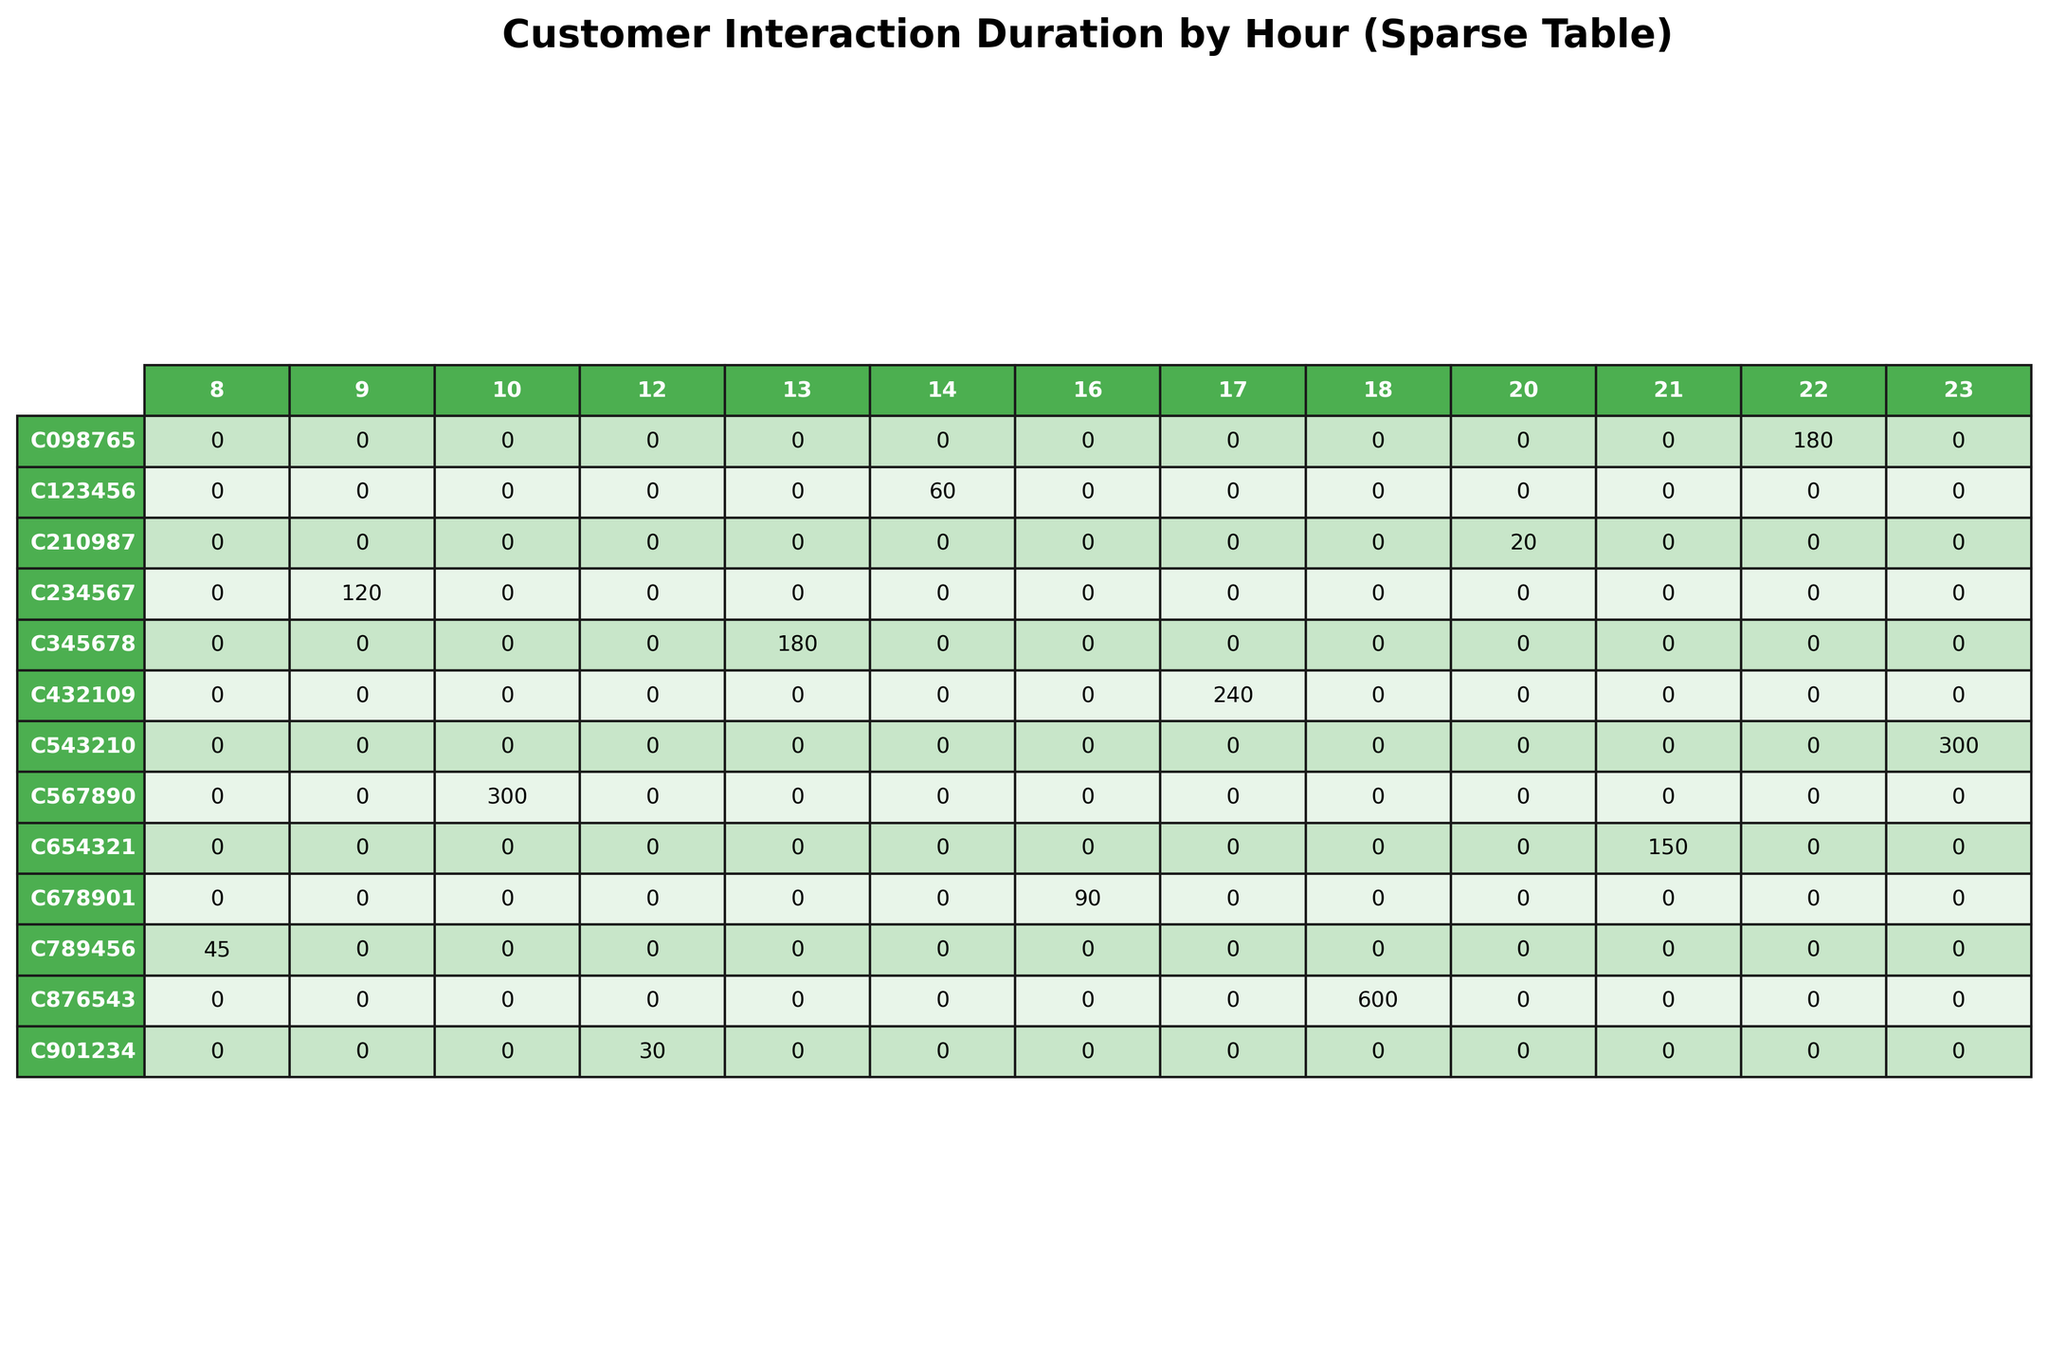What is the total interaction duration for customer C567890? The interaction duration for customer C567890 can be found in the table under their row. It shows a total of 300 seconds across the hours listed.
Answer: 300 seconds Which customer had the longest interaction time during the hour of 12 PM? By examining the table for the 12 PM column, we see that the customer with ID C901234 had an interaction duration of 30 seconds, which is the only entry for that hour.
Answer: C901234 How many total seconds did customer C789456 spend interacting with products during all hours? Looking at the row for customer C789456, the total duration is 45 seconds, which is the only entry for this customer across all hours.
Answer: 45 seconds Did any customer add products to their cart during the peak time of 8 AM to 12 PM? We examine the interactions during the hours from 8 AM to 12 PM and find that customer C234567 added a product to the cart at 9:30 AM for a duration of 120 seconds. Therefore, the answer is yes.
Answer: Yes What is the average interaction duration for all customers during the hour of 9 AM? The only entry in the table for 9 AM is customer C234567 with a duration of 120 seconds. Since there is only one entry, the average calculation is straightforward: 120 seconds / 1 = 120 seconds.
Answer: 120 seconds Which interaction type occurred the most during the 10 AM hour, and what was the duration associated with it? At 10 AM, only customer C567890 made a purchase, lasting for 300 seconds. Thus, the interaction type for 10 AM is purchase, with a duration of 300 seconds.
Answer: purchase (300 seconds) How does the interaction duration of customer C432109 compare to the average of all customers? Customer C432109 has a total duration of 240 seconds during the hour of 5 PM. The average interaction duration across all customers can be obtained by summing the duration entries and dividing them by the total number of unique customers, which equals 186 seconds. Since 240 seconds is greater than 186 seconds, C432109's duration is above average.
Answer: Above average Identify the customer with the maximum interaction duration overall and state their total duration. By scanning through all rows in the table, we see that customer C678901 has the maximal interaction duration of 600 seconds for a customer support interaction.
Answer: C678901 (600 seconds) How many customers did not interact with any products between 11 AM and 12 PM? In the time range of 11 AM to 12 PM, we examine the respective rows for any entries. The only interaction during this range is by C901234, which means the customers C789456, C234567, C567890, C345678, C123456, C678901, C432109, C876543, C210987, C654321, C098765, and C543210 did not interact, totaling 11 customers.
Answer: 11 customers What is the total cart value for all customers who made purchases? Looking at the table, customers who made a purchase are C567890 (249.95) and C098765 (299.97). Therefore, the total cart value for purchases can be calculated as 249.95 + 299.97 = 549.92.
Answer: 549.92 